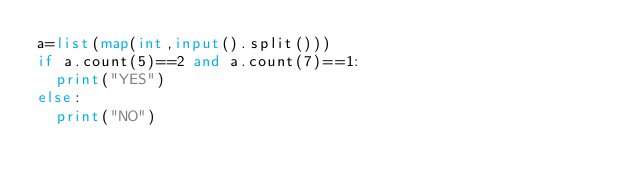<code> <loc_0><loc_0><loc_500><loc_500><_Python_>a=list(map(int,input().split()))
if a.count(5)==2 and a.count(7)==1:
  print("YES")
else:
  print("NO")</code> 